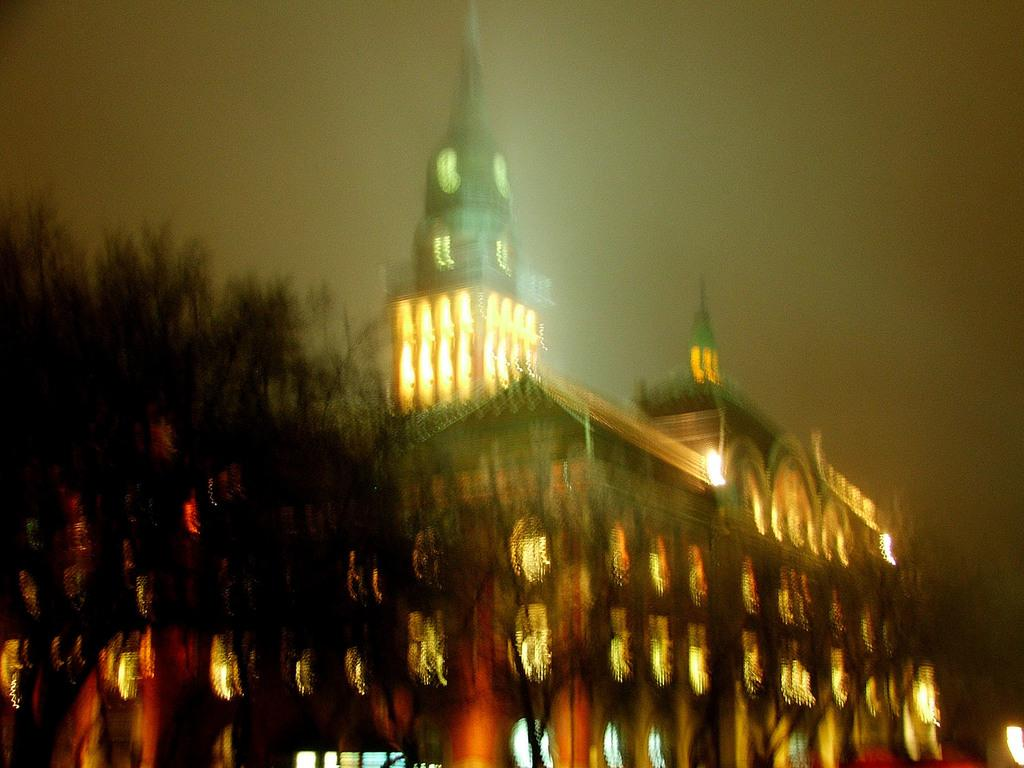What type of structure is present in the image? There is a building in the image. What other natural elements can be seen in the image? There are trees in the image. What part of the natural environment is visible in the image? The sky is visible in the background of the image. What time of day is it in the image, and what type of cattle can be seen grazing in the field? The time of day is not mentioned in the image, and there are no cattle present in the image. 